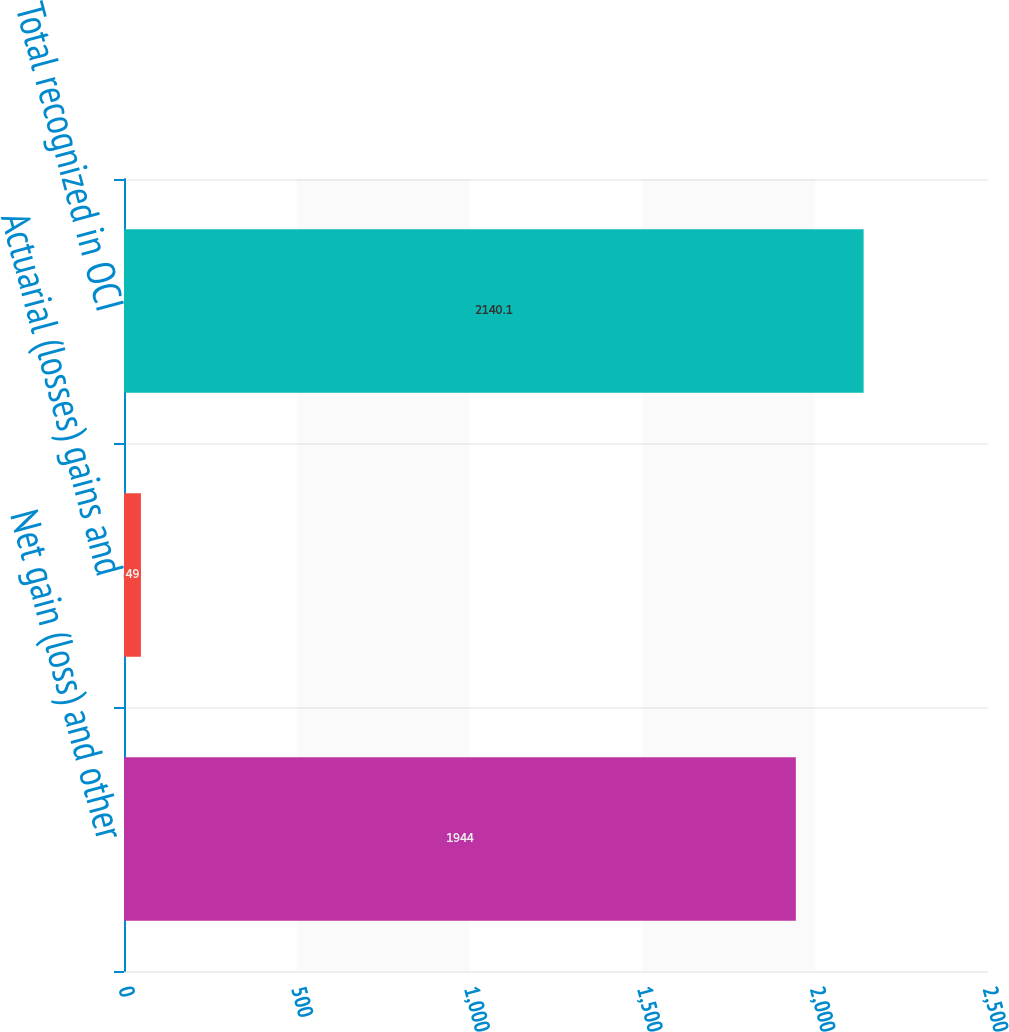<chart> <loc_0><loc_0><loc_500><loc_500><bar_chart><fcel>Net gain (loss) and other<fcel>Actuarial (losses) gains and<fcel>Total recognized in OCI<nl><fcel>1944<fcel>49<fcel>2140.1<nl></chart> 